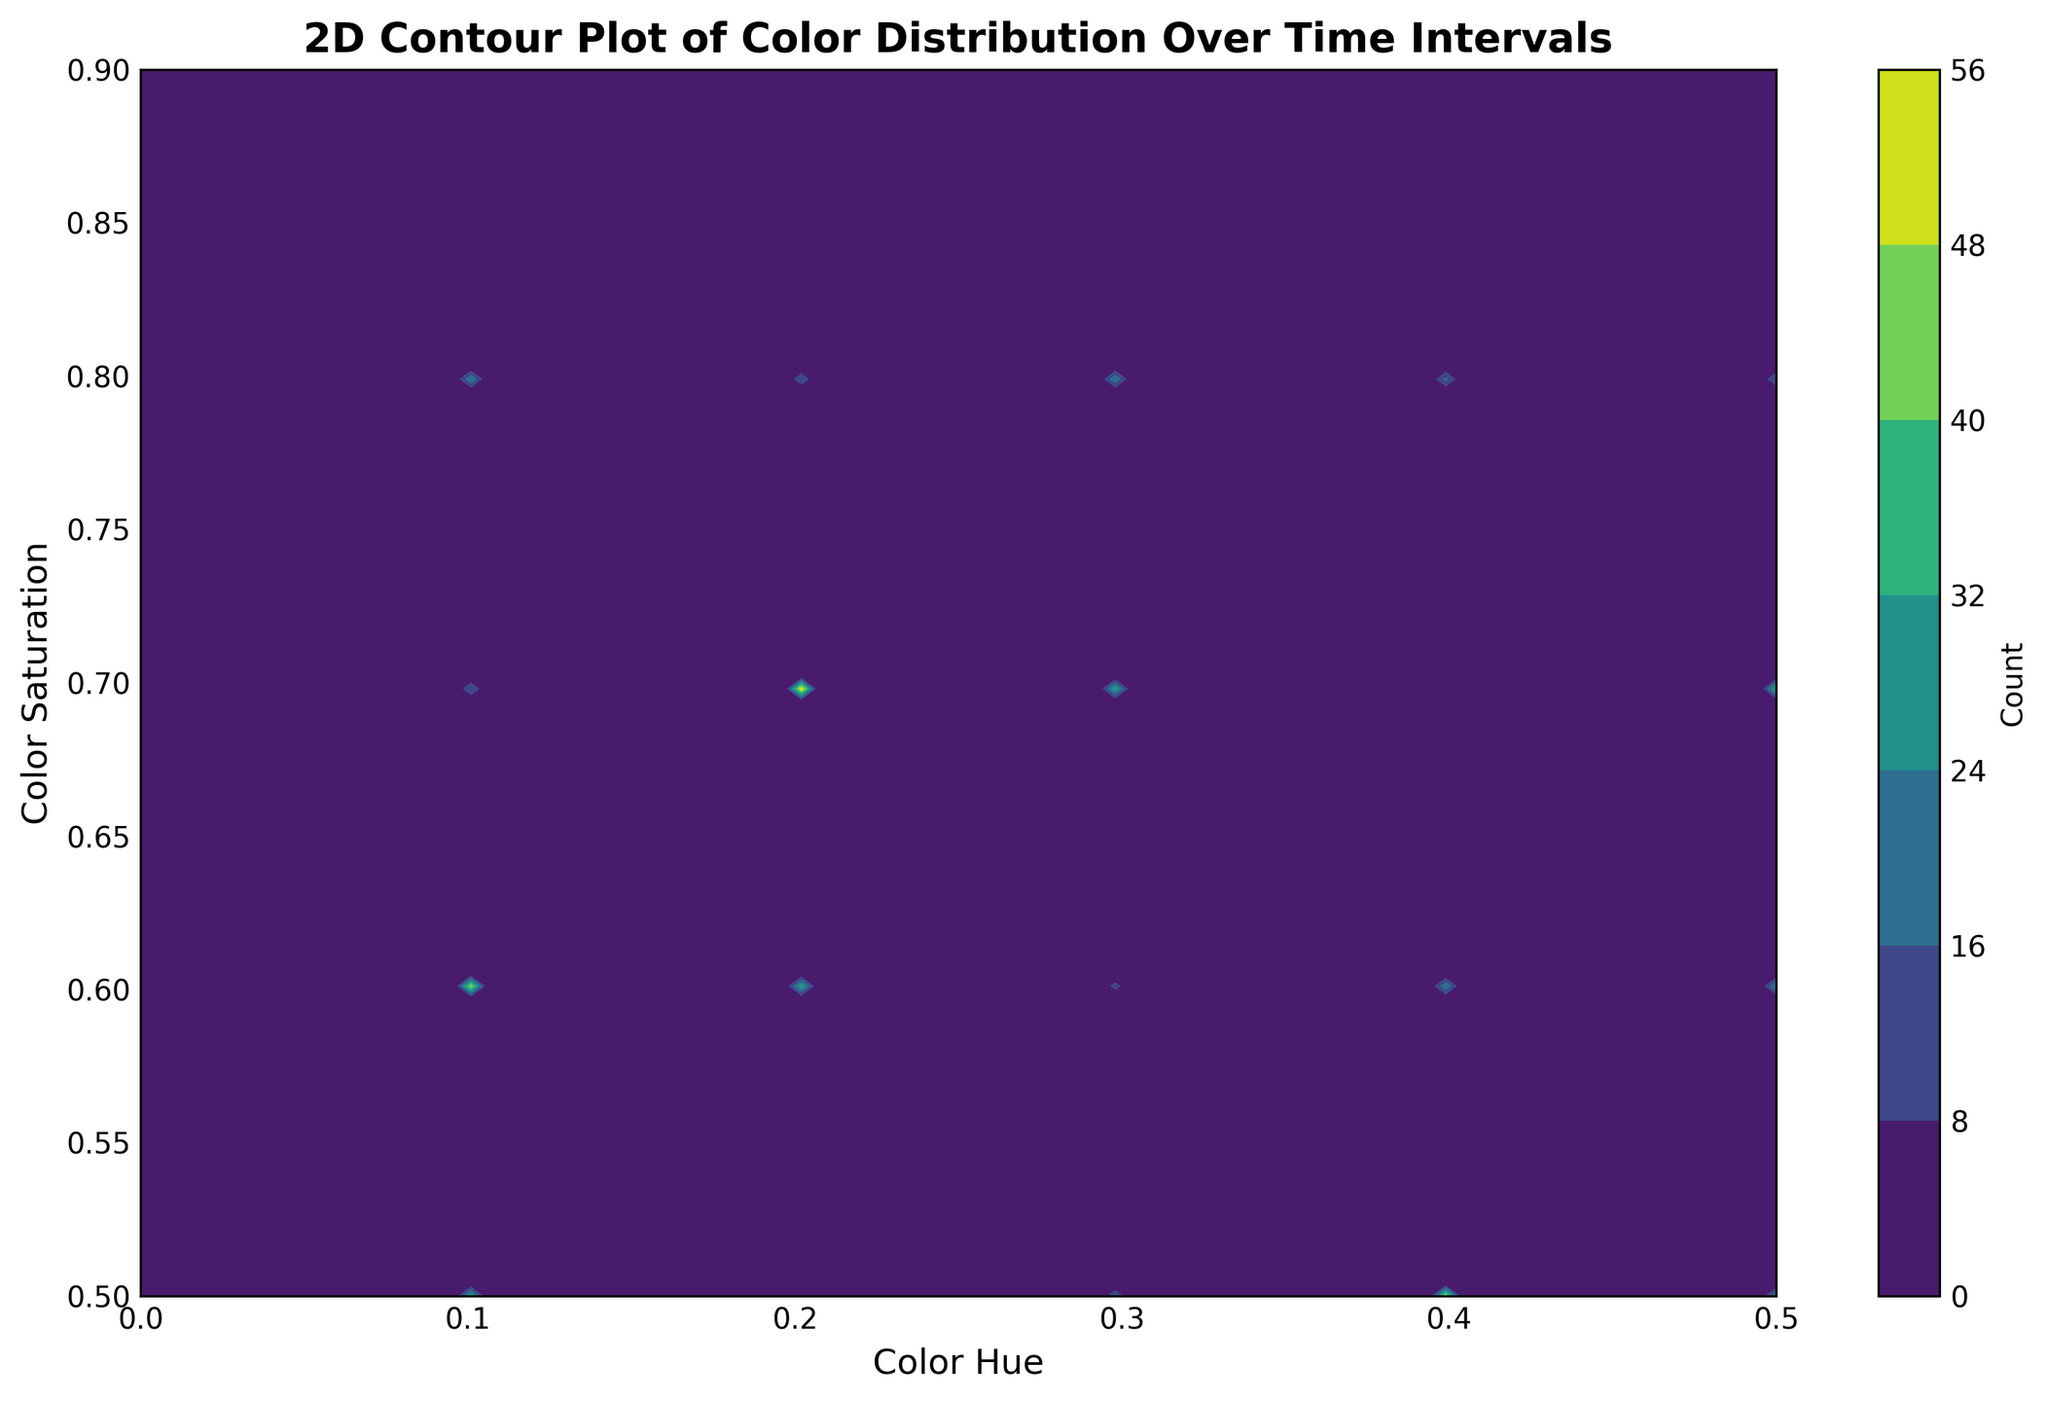What is the highest concentration area of color hues on the contour plot? To find the highest concentration area of color hues, look at the regions with the darkest shades on the contour plot. The contour plot uses color intensity to represent different concentration levels, where darker shades indicate higher concentrations. Specifically, identify the grid location with the highest color intensity within the plot boundaries.
Answer: Around 0.3 hue and 0.7 saturation Which time interval shows the highest number of color counts? Examine the color intensity of the contour plot for different ranges representing time intervals. The highest number of color counts will be reflected by the darkest or most intense color on the plot. By focusing on these darkest areas, you can deduce which time interval corresponds to these regions.
Answer: 20-25 How does the color distribution change from the 0-5 to 20-25 time interval? Look at the contour areas representing these time intervals and compare the hue and saturation distributions. Notice the variation in color intensity and spread within these ranges. For more clarity, focus on the central concentration areas and note any shifts in the hue and saturation values.
Answer: The central concentration shifts toward lower hues and higher saturations in the 20-25 interval What is the average color value for the 5-10 time interval based on the figure? To find the average color value, identify all the relevant points corresponding to the 5-10 interval on the contour plot. Note their Color Value and Count, multiply each Color Value by its Count, sum these products, and then divide by the total count.
Answer: 0.8 Compare the color saturation distribution between the 10-15 and 25-30 time intervals. Which interval shows higher saturation? Examine the contour plot areas representing the 10-15 and 25-30 time intervals. Higher saturation regions are closer to the top boundary of the plot. Compare these areas based on color intensity to identify which interval shows higher saturation.
Answer: 10-15 Which hue range has the highest count for the 15-20 time interval? Focus on the contour plot section for the 15-20 time interval. Observe the grid's darkest or most intense colors to determine which hue range corresponds to these regions, indicating the highest count.
Answer: Around 0.1-0.2 What is the pattern in hue distribution as the time interval progresses from 0-5 to 25-30? Look at the contour plot across all time intervals. Track the areas with high-intensity colors to identify any patterns or trends in the hue distribution, such as shifts or concentrations moving toward certain hue values.
Answer: Pattern shifts toward increasing hues Can you identify any outliers in the color distribution for any of the time intervals? Scan the contour plot to identify any unusual regions where the color intensity drastically differs from the surrounding areas. These would likely represent outliers in the color distribution.
Answer: Around 0.3 Hue in the 10-15 interval Does the contour plot suggest any preference for specific color values during any of the intervals? Observe the contours for any concentrated high bins corresponding to specific color values across the intervals. Intense color regions indicate a preference for specific color values.
Answer: Preference for 0.85-0.9 What trends do you see in the saturation levels from the 0-5 to the 25-30 time interval? Examine the contour plot's vertical spread across the time intervals, focusing on the saturation axis. Identify changes in the bands where the highest concentration of colors is noted, indicating a trend.
Answer: Increasing tendency towards higher saturations 